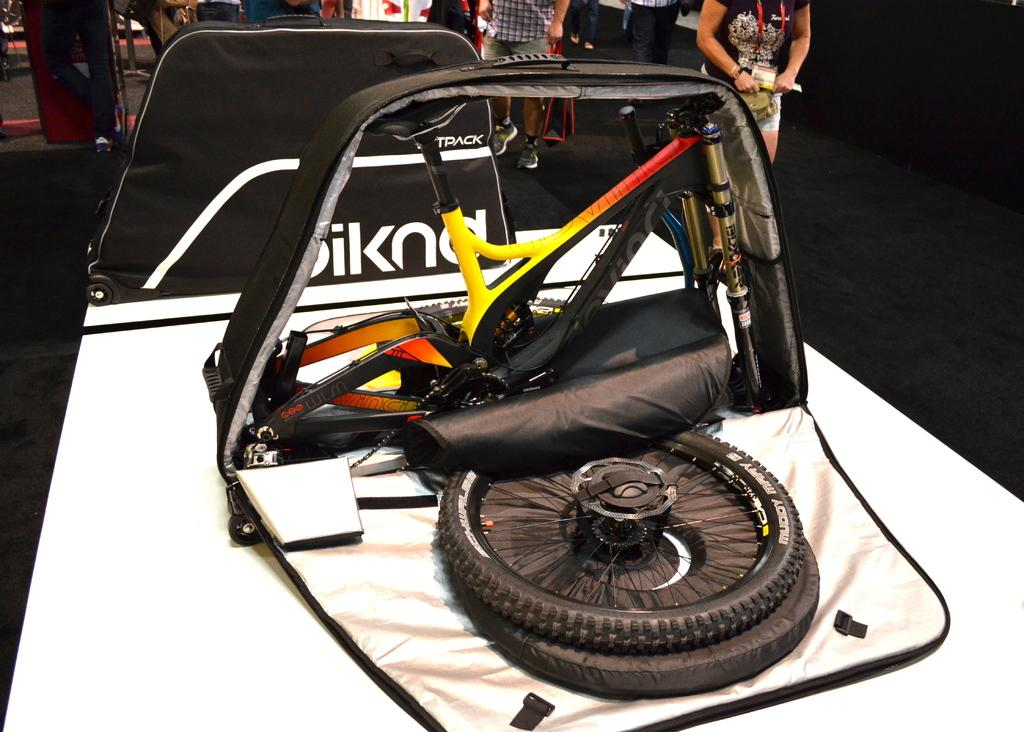What is the main subject of the image? The main subject of the image is an expo of vehicles. Can you describe the people in the image? Many people are standing behind the vehicles in the image. What type of mountain can be seen in the background of the image? There is no mountain visible in the background of the image; it features an expo of vehicles and people standing behind them. Are there any fairies flying around the vehicles in the image? There are no fairies present in the image; it only shows an expo of vehicles and people standing behind them. 